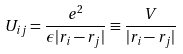Convert formula to latex. <formula><loc_0><loc_0><loc_500><loc_500>U _ { i j } = \frac { e ^ { 2 } } { \epsilon | r _ { i } - r _ { j } | } \equiv \frac { V } { | r _ { i } - r _ { j } | }</formula> 